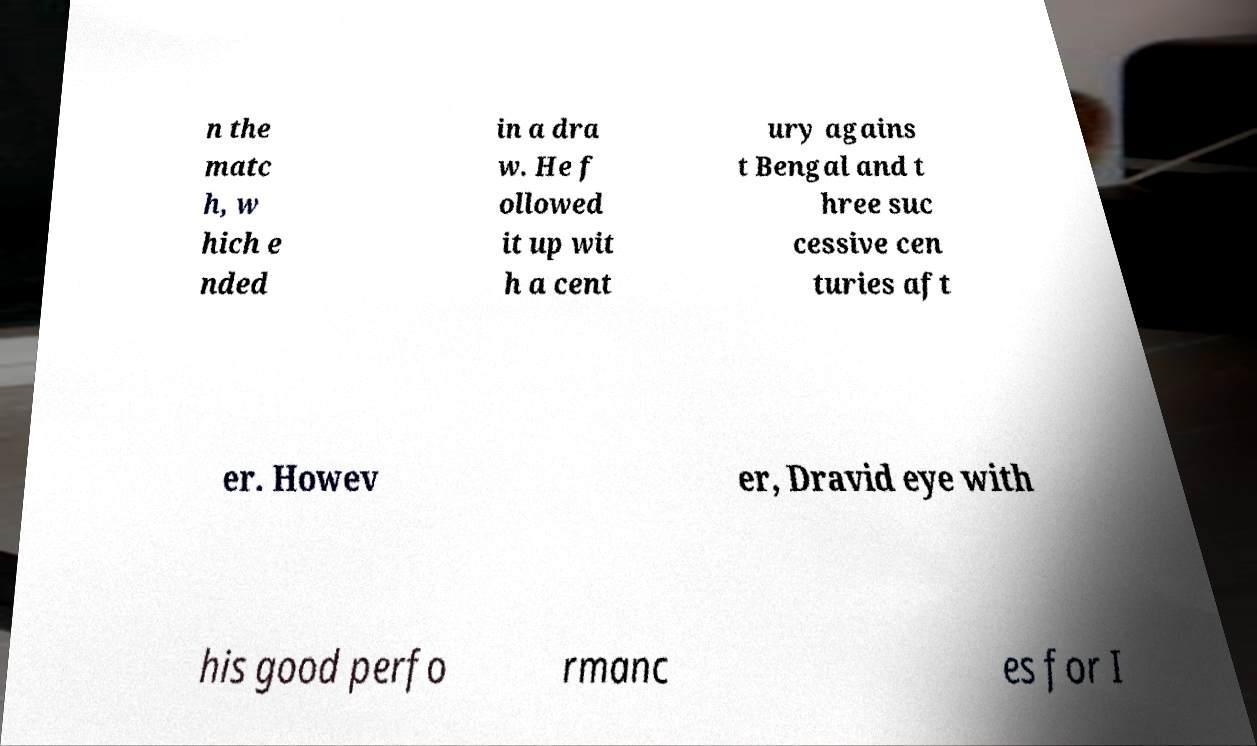Could you extract and type out the text from this image? n the matc h, w hich e nded in a dra w. He f ollowed it up wit h a cent ury agains t Bengal and t hree suc cessive cen turies aft er. Howev er, Dravid eye with his good perfo rmanc es for I 